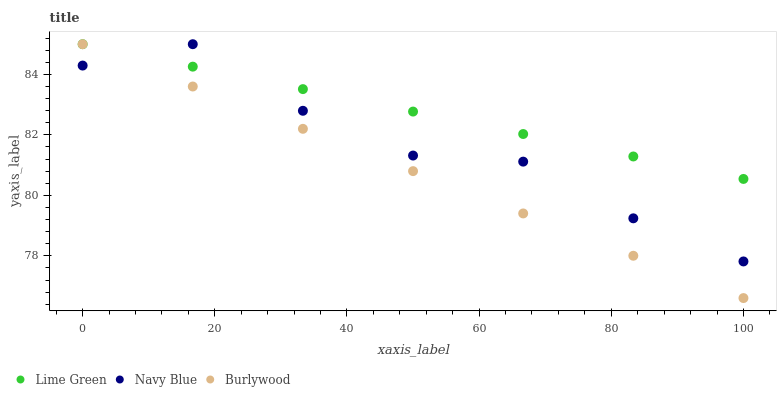Does Burlywood have the minimum area under the curve?
Answer yes or no. Yes. Does Lime Green have the maximum area under the curve?
Answer yes or no. Yes. Does Navy Blue have the minimum area under the curve?
Answer yes or no. No. Does Navy Blue have the maximum area under the curve?
Answer yes or no. No. Is Lime Green the smoothest?
Answer yes or no. Yes. Is Navy Blue the roughest?
Answer yes or no. Yes. Is Navy Blue the smoothest?
Answer yes or no. No. Is Lime Green the roughest?
Answer yes or no. No. Does Burlywood have the lowest value?
Answer yes or no. Yes. Does Navy Blue have the lowest value?
Answer yes or no. No. Does Lime Green have the highest value?
Answer yes or no. Yes. Does Navy Blue intersect Burlywood?
Answer yes or no. Yes. Is Navy Blue less than Burlywood?
Answer yes or no. No. Is Navy Blue greater than Burlywood?
Answer yes or no. No. 